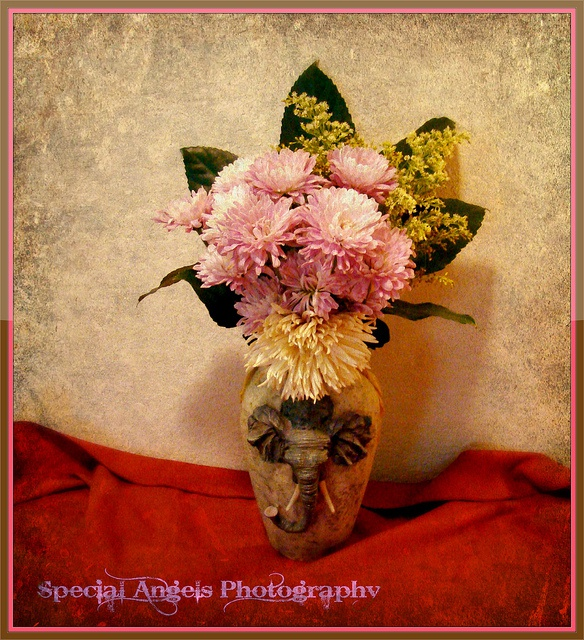Describe the objects in this image and their specific colors. I can see a vase in tan, maroon, brown, and black tones in this image. 